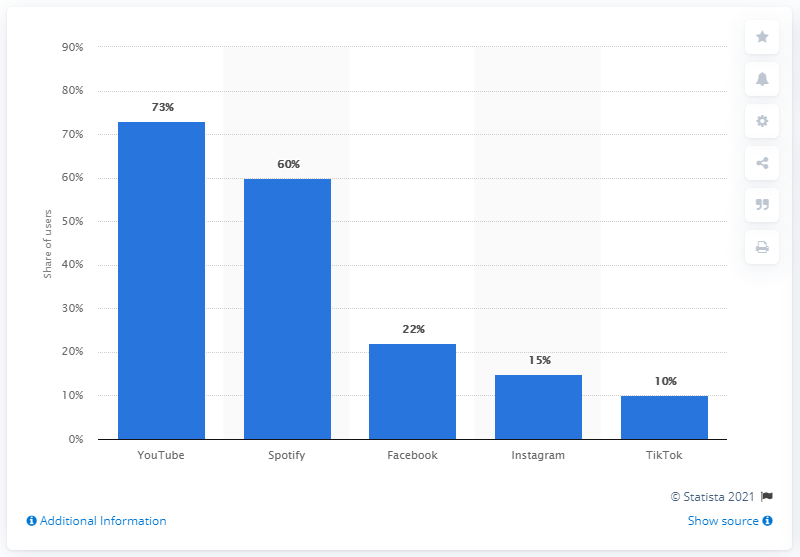Indicate a few pertinent items in this graphic. According to the information available, Spotify was the second most popular online music service in Norway. YouTube was the most widely used digital music service among Norwegians. 